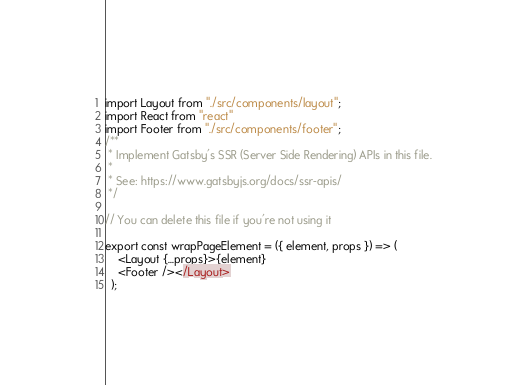Convert code to text. <code><loc_0><loc_0><loc_500><loc_500><_JavaScript_>import Layout from "./src/components/layout";
import React from "react"
import Footer from "./src/components/footer";
/**
 * Implement Gatsby's SSR (Server Side Rendering) APIs in this file.
 *
 * See: https://www.gatsbyjs.org/docs/ssr-apis/
 */

// You can delete this file if you're not using it

export const wrapPageElement = ({ element, props }) => (
    <Layout {...props}>{element}
    <Footer /></Layout>
  );</code> 